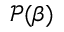Convert formula to latex. <formula><loc_0><loc_0><loc_500><loc_500>\ m a t h s c r { P } ( \beta )</formula> 